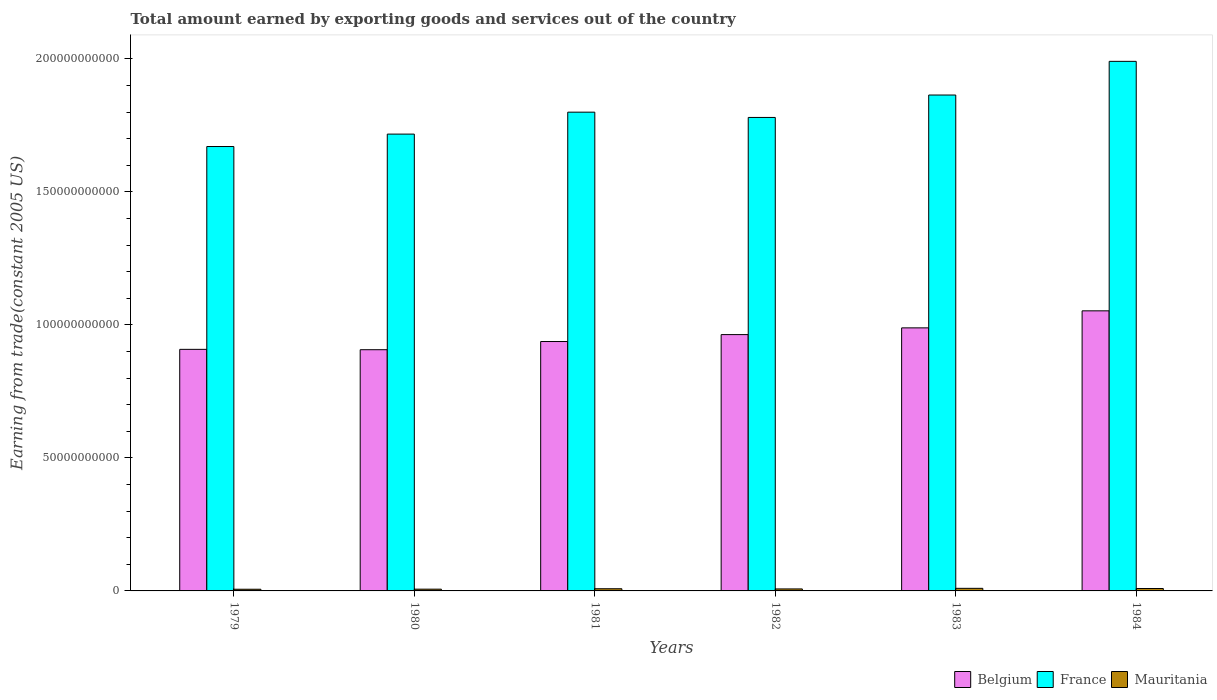How many different coloured bars are there?
Offer a very short reply. 3. Are the number of bars on each tick of the X-axis equal?
Your answer should be very brief. Yes. How many bars are there on the 2nd tick from the left?
Ensure brevity in your answer.  3. What is the label of the 2nd group of bars from the left?
Your answer should be compact. 1980. What is the total amount earned by exporting goods and services in Belgium in 1980?
Your answer should be compact. 9.07e+1. Across all years, what is the maximum total amount earned by exporting goods and services in Belgium?
Give a very brief answer. 1.05e+11. Across all years, what is the minimum total amount earned by exporting goods and services in Belgium?
Make the answer very short. 9.07e+1. In which year was the total amount earned by exporting goods and services in France minimum?
Ensure brevity in your answer.  1979. What is the total total amount earned by exporting goods and services in France in the graph?
Your response must be concise. 1.08e+12. What is the difference between the total amount earned by exporting goods and services in Belgium in 1979 and that in 1983?
Provide a succinct answer. -8.07e+09. What is the difference between the total amount earned by exporting goods and services in Belgium in 1982 and the total amount earned by exporting goods and services in Mauritania in 1983?
Provide a succinct answer. 9.54e+1. What is the average total amount earned by exporting goods and services in Mauritania per year?
Ensure brevity in your answer.  7.90e+08. In the year 1983, what is the difference between the total amount earned by exporting goods and services in Mauritania and total amount earned by exporting goods and services in Belgium?
Provide a succinct answer. -9.79e+1. In how many years, is the total amount earned by exporting goods and services in Belgium greater than 90000000000 US$?
Offer a terse response. 6. What is the ratio of the total amount earned by exporting goods and services in Belgium in 1980 to that in 1981?
Give a very brief answer. 0.97. Is the total amount earned by exporting goods and services in France in 1981 less than that in 1983?
Provide a short and direct response. Yes. Is the difference between the total amount earned by exporting goods and services in Mauritania in 1982 and 1983 greater than the difference between the total amount earned by exporting goods and services in Belgium in 1982 and 1983?
Your response must be concise. Yes. What is the difference between the highest and the second highest total amount earned by exporting goods and services in France?
Your answer should be compact. 1.27e+1. What is the difference between the highest and the lowest total amount earned by exporting goods and services in Belgium?
Your response must be concise. 1.46e+1. In how many years, is the total amount earned by exporting goods and services in France greater than the average total amount earned by exporting goods and services in France taken over all years?
Give a very brief answer. 2. Is the sum of the total amount earned by exporting goods and services in Mauritania in 1982 and 1984 greater than the maximum total amount earned by exporting goods and services in France across all years?
Provide a succinct answer. No. What does the 2nd bar from the left in 1979 represents?
Your answer should be compact. France. What does the 2nd bar from the right in 1980 represents?
Offer a very short reply. France. What is the difference between two consecutive major ticks on the Y-axis?
Ensure brevity in your answer.  5.00e+1. Are the values on the major ticks of Y-axis written in scientific E-notation?
Make the answer very short. No. Does the graph contain any zero values?
Keep it short and to the point. No. Where does the legend appear in the graph?
Offer a very short reply. Bottom right. How many legend labels are there?
Give a very brief answer. 3. What is the title of the graph?
Your answer should be compact. Total amount earned by exporting goods and services out of the country. Does "Cambodia" appear as one of the legend labels in the graph?
Keep it short and to the point. No. What is the label or title of the X-axis?
Provide a succinct answer. Years. What is the label or title of the Y-axis?
Your answer should be very brief. Earning from trade(constant 2005 US). What is the Earning from trade(constant 2005 US) in Belgium in 1979?
Offer a very short reply. 9.08e+1. What is the Earning from trade(constant 2005 US) of France in 1979?
Provide a succinct answer. 1.67e+11. What is the Earning from trade(constant 2005 US) of Mauritania in 1979?
Your response must be concise. 6.30e+08. What is the Earning from trade(constant 2005 US) in Belgium in 1980?
Your answer should be compact. 9.07e+1. What is the Earning from trade(constant 2005 US) in France in 1980?
Ensure brevity in your answer.  1.72e+11. What is the Earning from trade(constant 2005 US) in Mauritania in 1980?
Your answer should be very brief. 6.63e+08. What is the Earning from trade(constant 2005 US) of Belgium in 1981?
Keep it short and to the point. 9.38e+1. What is the Earning from trade(constant 2005 US) in France in 1981?
Keep it short and to the point. 1.80e+11. What is the Earning from trade(constant 2005 US) of Mauritania in 1981?
Give a very brief answer. 8.16e+08. What is the Earning from trade(constant 2005 US) of Belgium in 1982?
Your response must be concise. 9.64e+1. What is the Earning from trade(constant 2005 US) in France in 1982?
Your answer should be very brief. 1.78e+11. What is the Earning from trade(constant 2005 US) of Mauritania in 1982?
Keep it short and to the point. 7.49e+08. What is the Earning from trade(constant 2005 US) in Belgium in 1983?
Offer a terse response. 9.89e+1. What is the Earning from trade(constant 2005 US) in France in 1983?
Offer a terse response. 1.86e+11. What is the Earning from trade(constant 2005 US) of Mauritania in 1983?
Provide a succinct answer. 9.72e+08. What is the Earning from trade(constant 2005 US) of Belgium in 1984?
Ensure brevity in your answer.  1.05e+11. What is the Earning from trade(constant 2005 US) of France in 1984?
Provide a succinct answer. 1.99e+11. What is the Earning from trade(constant 2005 US) in Mauritania in 1984?
Your answer should be compact. 9.08e+08. Across all years, what is the maximum Earning from trade(constant 2005 US) of Belgium?
Offer a terse response. 1.05e+11. Across all years, what is the maximum Earning from trade(constant 2005 US) of France?
Keep it short and to the point. 1.99e+11. Across all years, what is the maximum Earning from trade(constant 2005 US) of Mauritania?
Your response must be concise. 9.72e+08. Across all years, what is the minimum Earning from trade(constant 2005 US) of Belgium?
Provide a short and direct response. 9.07e+1. Across all years, what is the minimum Earning from trade(constant 2005 US) of France?
Ensure brevity in your answer.  1.67e+11. Across all years, what is the minimum Earning from trade(constant 2005 US) of Mauritania?
Offer a terse response. 6.30e+08. What is the total Earning from trade(constant 2005 US) in Belgium in the graph?
Offer a terse response. 5.76e+11. What is the total Earning from trade(constant 2005 US) in France in the graph?
Your response must be concise. 1.08e+12. What is the total Earning from trade(constant 2005 US) in Mauritania in the graph?
Your response must be concise. 4.74e+09. What is the difference between the Earning from trade(constant 2005 US) of Belgium in 1979 and that in 1980?
Offer a terse response. 1.37e+08. What is the difference between the Earning from trade(constant 2005 US) in France in 1979 and that in 1980?
Provide a succinct answer. -4.67e+09. What is the difference between the Earning from trade(constant 2005 US) in Mauritania in 1979 and that in 1980?
Your response must be concise. -3.37e+07. What is the difference between the Earning from trade(constant 2005 US) of Belgium in 1979 and that in 1981?
Your response must be concise. -2.94e+09. What is the difference between the Earning from trade(constant 2005 US) in France in 1979 and that in 1981?
Your answer should be compact. -1.29e+1. What is the difference between the Earning from trade(constant 2005 US) of Mauritania in 1979 and that in 1981?
Keep it short and to the point. -1.87e+08. What is the difference between the Earning from trade(constant 2005 US) in Belgium in 1979 and that in 1982?
Your answer should be very brief. -5.54e+09. What is the difference between the Earning from trade(constant 2005 US) of France in 1979 and that in 1982?
Your answer should be very brief. -1.09e+1. What is the difference between the Earning from trade(constant 2005 US) in Mauritania in 1979 and that in 1982?
Your answer should be compact. -1.19e+08. What is the difference between the Earning from trade(constant 2005 US) in Belgium in 1979 and that in 1983?
Your answer should be very brief. -8.07e+09. What is the difference between the Earning from trade(constant 2005 US) in France in 1979 and that in 1983?
Offer a very short reply. -1.94e+1. What is the difference between the Earning from trade(constant 2005 US) in Mauritania in 1979 and that in 1983?
Make the answer very short. -3.42e+08. What is the difference between the Earning from trade(constant 2005 US) in Belgium in 1979 and that in 1984?
Give a very brief answer. -1.45e+1. What is the difference between the Earning from trade(constant 2005 US) in France in 1979 and that in 1984?
Offer a terse response. -3.20e+1. What is the difference between the Earning from trade(constant 2005 US) of Mauritania in 1979 and that in 1984?
Offer a terse response. -2.78e+08. What is the difference between the Earning from trade(constant 2005 US) of Belgium in 1980 and that in 1981?
Provide a short and direct response. -3.08e+09. What is the difference between the Earning from trade(constant 2005 US) of France in 1980 and that in 1981?
Offer a very short reply. -8.25e+09. What is the difference between the Earning from trade(constant 2005 US) in Mauritania in 1980 and that in 1981?
Offer a very short reply. -1.53e+08. What is the difference between the Earning from trade(constant 2005 US) of Belgium in 1980 and that in 1982?
Offer a terse response. -5.68e+09. What is the difference between the Earning from trade(constant 2005 US) of France in 1980 and that in 1982?
Your answer should be very brief. -6.26e+09. What is the difference between the Earning from trade(constant 2005 US) in Mauritania in 1980 and that in 1982?
Make the answer very short. -8.58e+07. What is the difference between the Earning from trade(constant 2005 US) in Belgium in 1980 and that in 1983?
Your answer should be very brief. -8.21e+09. What is the difference between the Earning from trade(constant 2005 US) in France in 1980 and that in 1983?
Provide a succinct answer. -1.47e+1. What is the difference between the Earning from trade(constant 2005 US) in Mauritania in 1980 and that in 1983?
Offer a very short reply. -3.09e+08. What is the difference between the Earning from trade(constant 2005 US) of Belgium in 1980 and that in 1984?
Make the answer very short. -1.46e+1. What is the difference between the Earning from trade(constant 2005 US) of France in 1980 and that in 1984?
Ensure brevity in your answer.  -2.73e+1. What is the difference between the Earning from trade(constant 2005 US) of Mauritania in 1980 and that in 1984?
Ensure brevity in your answer.  -2.45e+08. What is the difference between the Earning from trade(constant 2005 US) of Belgium in 1981 and that in 1982?
Give a very brief answer. -2.61e+09. What is the difference between the Earning from trade(constant 2005 US) of France in 1981 and that in 1982?
Make the answer very short. 1.98e+09. What is the difference between the Earning from trade(constant 2005 US) of Mauritania in 1981 and that in 1982?
Offer a very short reply. 6.73e+07. What is the difference between the Earning from trade(constant 2005 US) in Belgium in 1981 and that in 1983?
Ensure brevity in your answer.  -5.14e+09. What is the difference between the Earning from trade(constant 2005 US) in France in 1981 and that in 1983?
Provide a succinct answer. -6.44e+09. What is the difference between the Earning from trade(constant 2005 US) of Mauritania in 1981 and that in 1983?
Provide a succinct answer. -1.55e+08. What is the difference between the Earning from trade(constant 2005 US) in Belgium in 1981 and that in 1984?
Offer a terse response. -1.15e+1. What is the difference between the Earning from trade(constant 2005 US) of France in 1981 and that in 1984?
Provide a succinct answer. -1.91e+1. What is the difference between the Earning from trade(constant 2005 US) of Mauritania in 1981 and that in 1984?
Provide a succinct answer. -9.16e+07. What is the difference between the Earning from trade(constant 2005 US) in Belgium in 1982 and that in 1983?
Provide a succinct answer. -2.53e+09. What is the difference between the Earning from trade(constant 2005 US) in France in 1982 and that in 1983?
Make the answer very short. -8.42e+09. What is the difference between the Earning from trade(constant 2005 US) in Mauritania in 1982 and that in 1983?
Make the answer very short. -2.23e+08. What is the difference between the Earning from trade(constant 2005 US) of Belgium in 1982 and that in 1984?
Keep it short and to the point. -8.93e+09. What is the difference between the Earning from trade(constant 2005 US) in France in 1982 and that in 1984?
Offer a terse response. -2.11e+1. What is the difference between the Earning from trade(constant 2005 US) of Mauritania in 1982 and that in 1984?
Provide a short and direct response. -1.59e+08. What is the difference between the Earning from trade(constant 2005 US) in Belgium in 1983 and that in 1984?
Your answer should be compact. -6.40e+09. What is the difference between the Earning from trade(constant 2005 US) of France in 1983 and that in 1984?
Ensure brevity in your answer.  -1.27e+1. What is the difference between the Earning from trade(constant 2005 US) of Mauritania in 1983 and that in 1984?
Give a very brief answer. 6.39e+07. What is the difference between the Earning from trade(constant 2005 US) of Belgium in 1979 and the Earning from trade(constant 2005 US) of France in 1980?
Give a very brief answer. -8.09e+1. What is the difference between the Earning from trade(constant 2005 US) in Belgium in 1979 and the Earning from trade(constant 2005 US) in Mauritania in 1980?
Give a very brief answer. 9.02e+1. What is the difference between the Earning from trade(constant 2005 US) of France in 1979 and the Earning from trade(constant 2005 US) of Mauritania in 1980?
Offer a terse response. 1.66e+11. What is the difference between the Earning from trade(constant 2005 US) in Belgium in 1979 and the Earning from trade(constant 2005 US) in France in 1981?
Give a very brief answer. -8.92e+1. What is the difference between the Earning from trade(constant 2005 US) in Belgium in 1979 and the Earning from trade(constant 2005 US) in Mauritania in 1981?
Keep it short and to the point. 9.00e+1. What is the difference between the Earning from trade(constant 2005 US) of France in 1979 and the Earning from trade(constant 2005 US) of Mauritania in 1981?
Offer a very short reply. 1.66e+11. What is the difference between the Earning from trade(constant 2005 US) in Belgium in 1979 and the Earning from trade(constant 2005 US) in France in 1982?
Provide a short and direct response. -8.72e+1. What is the difference between the Earning from trade(constant 2005 US) of Belgium in 1979 and the Earning from trade(constant 2005 US) of Mauritania in 1982?
Make the answer very short. 9.01e+1. What is the difference between the Earning from trade(constant 2005 US) in France in 1979 and the Earning from trade(constant 2005 US) in Mauritania in 1982?
Provide a short and direct response. 1.66e+11. What is the difference between the Earning from trade(constant 2005 US) of Belgium in 1979 and the Earning from trade(constant 2005 US) of France in 1983?
Your response must be concise. -9.56e+1. What is the difference between the Earning from trade(constant 2005 US) of Belgium in 1979 and the Earning from trade(constant 2005 US) of Mauritania in 1983?
Give a very brief answer. 8.98e+1. What is the difference between the Earning from trade(constant 2005 US) in France in 1979 and the Earning from trade(constant 2005 US) in Mauritania in 1983?
Ensure brevity in your answer.  1.66e+11. What is the difference between the Earning from trade(constant 2005 US) of Belgium in 1979 and the Earning from trade(constant 2005 US) of France in 1984?
Ensure brevity in your answer.  -1.08e+11. What is the difference between the Earning from trade(constant 2005 US) of Belgium in 1979 and the Earning from trade(constant 2005 US) of Mauritania in 1984?
Provide a succinct answer. 8.99e+1. What is the difference between the Earning from trade(constant 2005 US) in France in 1979 and the Earning from trade(constant 2005 US) in Mauritania in 1984?
Give a very brief answer. 1.66e+11. What is the difference between the Earning from trade(constant 2005 US) in Belgium in 1980 and the Earning from trade(constant 2005 US) in France in 1981?
Give a very brief answer. -8.93e+1. What is the difference between the Earning from trade(constant 2005 US) of Belgium in 1980 and the Earning from trade(constant 2005 US) of Mauritania in 1981?
Your answer should be very brief. 8.99e+1. What is the difference between the Earning from trade(constant 2005 US) of France in 1980 and the Earning from trade(constant 2005 US) of Mauritania in 1981?
Give a very brief answer. 1.71e+11. What is the difference between the Earning from trade(constant 2005 US) in Belgium in 1980 and the Earning from trade(constant 2005 US) in France in 1982?
Ensure brevity in your answer.  -8.73e+1. What is the difference between the Earning from trade(constant 2005 US) of Belgium in 1980 and the Earning from trade(constant 2005 US) of Mauritania in 1982?
Give a very brief answer. 8.99e+1. What is the difference between the Earning from trade(constant 2005 US) in France in 1980 and the Earning from trade(constant 2005 US) in Mauritania in 1982?
Offer a very short reply. 1.71e+11. What is the difference between the Earning from trade(constant 2005 US) in Belgium in 1980 and the Earning from trade(constant 2005 US) in France in 1983?
Your response must be concise. -9.57e+1. What is the difference between the Earning from trade(constant 2005 US) in Belgium in 1980 and the Earning from trade(constant 2005 US) in Mauritania in 1983?
Provide a succinct answer. 8.97e+1. What is the difference between the Earning from trade(constant 2005 US) in France in 1980 and the Earning from trade(constant 2005 US) in Mauritania in 1983?
Your response must be concise. 1.71e+11. What is the difference between the Earning from trade(constant 2005 US) in Belgium in 1980 and the Earning from trade(constant 2005 US) in France in 1984?
Keep it short and to the point. -1.08e+11. What is the difference between the Earning from trade(constant 2005 US) in Belgium in 1980 and the Earning from trade(constant 2005 US) in Mauritania in 1984?
Ensure brevity in your answer.  8.98e+1. What is the difference between the Earning from trade(constant 2005 US) in France in 1980 and the Earning from trade(constant 2005 US) in Mauritania in 1984?
Your answer should be compact. 1.71e+11. What is the difference between the Earning from trade(constant 2005 US) of Belgium in 1981 and the Earning from trade(constant 2005 US) of France in 1982?
Make the answer very short. -8.42e+1. What is the difference between the Earning from trade(constant 2005 US) of Belgium in 1981 and the Earning from trade(constant 2005 US) of Mauritania in 1982?
Your answer should be compact. 9.30e+1. What is the difference between the Earning from trade(constant 2005 US) of France in 1981 and the Earning from trade(constant 2005 US) of Mauritania in 1982?
Ensure brevity in your answer.  1.79e+11. What is the difference between the Earning from trade(constant 2005 US) of Belgium in 1981 and the Earning from trade(constant 2005 US) of France in 1983?
Offer a terse response. -9.27e+1. What is the difference between the Earning from trade(constant 2005 US) in Belgium in 1981 and the Earning from trade(constant 2005 US) in Mauritania in 1983?
Give a very brief answer. 9.28e+1. What is the difference between the Earning from trade(constant 2005 US) of France in 1981 and the Earning from trade(constant 2005 US) of Mauritania in 1983?
Make the answer very short. 1.79e+11. What is the difference between the Earning from trade(constant 2005 US) of Belgium in 1981 and the Earning from trade(constant 2005 US) of France in 1984?
Give a very brief answer. -1.05e+11. What is the difference between the Earning from trade(constant 2005 US) in Belgium in 1981 and the Earning from trade(constant 2005 US) in Mauritania in 1984?
Your answer should be very brief. 9.28e+1. What is the difference between the Earning from trade(constant 2005 US) in France in 1981 and the Earning from trade(constant 2005 US) in Mauritania in 1984?
Give a very brief answer. 1.79e+11. What is the difference between the Earning from trade(constant 2005 US) in Belgium in 1982 and the Earning from trade(constant 2005 US) in France in 1983?
Your answer should be compact. -9.01e+1. What is the difference between the Earning from trade(constant 2005 US) in Belgium in 1982 and the Earning from trade(constant 2005 US) in Mauritania in 1983?
Offer a very short reply. 9.54e+1. What is the difference between the Earning from trade(constant 2005 US) in France in 1982 and the Earning from trade(constant 2005 US) in Mauritania in 1983?
Keep it short and to the point. 1.77e+11. What is the difference between the Earning from trade(constant 2005 US) in Belgium in 1982 and the Earning from trade(constant 2005 US) in France in 1984?
Your response must be concise. -1.03e+11. What is the difference between the Earning from trade(constant 2005 US) in Belgium in 1982 and the Earning from trade(constant 2005 US) in Mauritania in 1984?
Make the answer very short. 9.54e+1. What is the difference between the Earning from trade(constant 2005 US) of France in 1982 and the Earning from trade(constant 2005 US) of Mauritania in 1984?
Keep it short and to the point. 1.77e+11. What is the difference between the Earning from trade(constant 2005 US) in Belgium in 1983 and the Earning from trade(constant 2005 US) in France in 1984?
Give a very brief answer. -1.00e+11. What is the difference between the Earning from trade(constant 2005 US) of Belgium in 1983 and the Earning from trade(constant 2005 US) of Mauritania in 1984?
Your answer should be compact. 9.80e+1. What is the difference between the Earning from trade(constant 2005 US) of France in 1983 and the Earning from trade(constant 2005 US) of Mauritania in 1984?
Your response must be concise. 1.86e+11. What is the average Earning from trade(constant 2005 US) of Belgium per year?
Provide a succinct answer. 9.60e+1. What is the average Earning from trade(constant 2005 US) in France per year?
Give a very brief answer. 1.80e+11. What is the average Earning from trade(constant 2005 US) in Mauritania per year?
Make the answer very short. 7.90e+08. In the year 1979, what is the difference between the Earning from trade(constant 2005 US) in Belgium and Earning from trade(constant 2005 US) in France?
Your answer should be compact. -7.62e+1. In the year 1979, what is the difference between the Earning from trade(constant 2005 US) in Belgium and Earning from trade(constant 2005 US) in Mauritania?
Provide a short and direct response. 9.02e+1. In the year 1979, what is the difference between the Earning from trade(constant 2005 US) of France and Earning from trade(constant 2005 US) of Mauritania?
Ensure brevity in your answer.  1.66e+11. In the year 1980, what is the difference between the Earning from trade(constant 2005 US) in Belgium and Earning from trade(constant 2005 US) in France?
Provide a succinct answer. -8.11e+1. In the year 1980, what is the difference between the Earning from trade(constant 2005 US) of Belgium and Earning from trade(constant 2005 US) of Mauritania?
Provide a succinct answer. 9.00e+1. In the year 1980, what is the difference between the Earning from trade(constant 2005 US) of France and Earning from trade(constant 2005 US) of Mauritania?
Provide a succinct answer. 1.71e+11. In the year 1981, what is the difference between the Earning from trade(constant 2005 US) of Belgium and Earning from trade(constant 2005 US) of France?
Offer a terse response. -8.62e+1. In the year 1981, what is the difference between the Earning from trade(constant 2005 US) of Belgium and Earning from trade(constant 2005 US) of Mauritania?
Your answer should be very brief. 9.29e+1. In the year 1981, what is the difference between the Earning from trade(constant 2005 US) of France and Earning from trade(constant 2005 US) of Mauritania?
Offer a terse response. 1.79e+11. In the year 1982, what is the difference between the Earning from trade(constant 2005 US) in Belgium and Earning from trade(constant 2005 US) in France?
Your answer should be compact. -8.16e+1. In the year 1982, what is the difference between the Earning from trade(constant 2005 US) in Belgium and Earning from trade(constant 2005 US) in Mauritania?
Keep it short and to the point. 9.56e+1. In the year 1982, what is the difference between the Earning from trade(constant 2005 US) of France and Earning from trade(constant 2005 US) of Mauritania?
Your answer should be very brief. 1.77e+11. In the year 1983, what is the difference between the Earning from trade(constant 2005 US) in Belgium and Earning from trade(constant 2005 US) in France?
Ensure brevity in your answer.  -8.75e+1. In the year 1983, what is the difference between the Earning from trade(constant 2005 US) in Belgium and Earning from trade(constant 2005 US) in Mauritania?
Make the answer very short. 9.79e+1. In the year 1983, what is the difference between the Earning from trade(constant 2005 US) of France and Earning from trade(constant 2005 US) of Mauritania?
Ensure brevity in your answer.  1.85e+11. In the year 1984, what is the difference between the Earning from trade(constant 2005 US) of Belgium and Earning from trade(constant 2005 US) of France?
Give a very brief answer. -9.38e+1. In the year 1984, what is the difference between the Earning from trade(constant 2005 US) in Belgium and Earning from trade(constant 2005 US) in Mauritania?
Offer a very short reply. 1.04e+11. In the year 1984, what is the difference between the Earning from trade(constant 2005 US) in France and Earning from trade(constant 2005 US) in Mauritania?
Your answer should be very brief. 1.98e+11. What is the ratio of the Earning from trade(constant 2005 US) of Belgium in 1979 to that in 1980?
Your response must be concise. 1. What is the ratio of the Earning from trade(constant 2005 US) in France in 1979 to that in 1980?
Make the answer very short. 0.97. What is the ratio of the Earning from trade(constant 2005 US) of Mauritania in 1979 to that in 1980?
Your response must be concise. 0.95. What is the ratio of the Earning from trade(constant 2005 US) in Belgium in 1979 to that in 1981?
Your answer should be very brief. 0.97. What is the ratio of the Earning from trade(constant 2005 US) in France in 1979 to that in 1981?
Your response must be concise. 0.93. What is the ratio of the Earning from trade(constant 2005 US) in Mauritania in 1979 to that in 1981?
Keep it short and to the point. 0.77. What is the ratio of the Earning from trade(constant 2005 US) of Belgium in 1979 to that in 1982?
Your answer should be compact. 0.94. What is the ratio of the Earning from trade(constant 2005 US) in France in 1979 to that in 1982?
Offer a very short reply. 0.94. What is the ratio of the Earning from trade(constant 2005 US) of Mauritania in 1979 to that in 1982?
Provide a short and direct response. 0.84. What is the ratio of the Earning from trade(constant 2005 US) in Belgium in 1979 to that in 1983?
Your answer should be compact. 0.92. What is the ratio of the Earning from trade(constant 2005 US) in France in 1979 to that in 1983?
Your answer should be very brief. 0.9. What is the ratio of the Earning from trade(constant 2005 US) of Mauritania in 1979 to that in 1983?
Your answer should be very brief. 0.65. What is the ratio of the Earning from trade(constant 2005 US) of Belgium in 1979 to that in 1984?
Provide a short and direct response. 0.86. What is the ratio of the Earning from trade(constant 2005 US) in France in 1979 to that in 1984?
Provide a short and direct response. 0.84. What is the ratio of the Earning from trade(constant 2005 US) of Mauritania in 1979 to that in 1984?
Offer a terse response. 0.69. What is the ratio of the Earning from trade(constant 2005 US) in Belgium in 1980 to that in 1981?
Your answer should be very brief. 0.97. What is the ratio of the Earning from trade(constant 2005 US) of France in 1980 to that in 1981?
Make the answer very short. 0.95. What is the ratio of the Earning from trade(constant 2005 US) in Mauritania in 1980 to that in 1981?
Make the answer very short. 0.81. What is the ratio of the Earning from trade(constant 2005 US) of Belgium in 1980 to that in 1982?
Ensure brevity in your answer.  0.94. What is the ratio of the Earning from trade(constant 2005 US) in France in 1980 to that in 1982?
Provide a short and direct response. 0.96. What is the ratio of the Earning from trade(constant 2005 US) of Mauritania in 1980 to that in 1982?
Provide a succinct answer. 0.89. What is the ratio of the Earning from trade(constant 2005 US) in Belgium in 1980 to that in 1983?
Provide a short and direct response. 0.92. What is the ratio of the Earning from trade(constant 2005 US) of France in 1980 to that in 1983?
Provide a succinct answer. 0.92. What is the ratio of the Earning from trade(constant 2005 US) of Mauritania in 1980 to that in 1983?
Offer a very short reply. 0.68. What is the ratio of the Earning from trade(constant 2005 US) in Belgium in 1980 to that in 1984?
Your response must be concise. 0.86. What is the ratio of the Earning from trade(constant 2005 US) of France in 1980 to that in 1984?
Make the answer very short. 0.86. What is the ratio of the Earning from trade(constant 2005 US) in Mauritania in 1980 to that in 1984?
Offer a terse response. 0.73. What is the ratio of the Earning from trade(constant 2005 US) in France in 1981 to that in 1982?
Offer a terse response. 1.01. What is the ratio of the Earning from trade(constant 2005 US) of Mauritania in 1981 to that in 1982?
Ensure brevity in your answer.  1.09. What is the ratio of the Earning from trade(constant 2005 US) in Belgium in 1981 to that in 1983?
Ensure brevity in your answer.  0.95. What is the ratio of the Earning from trade(constant 2005 US) in France in 1981 to that in 1983?
Keep it short and to the point. 0.97. What is the ratio of the Earning from trade(constant 2005 US) of Mauritania in 1981 to that in 1983?
Your response must be concise. 0.84. What is the ratio of the Earning from trade(constant 2005 US) in Belgium in 1981 to that in 1984?
Keep it short and to the point. 0.89. What is the ratio of the Earning from trade(constant 2005 US) in France in 1981 to that in 1984?
Make the answer very short. 0.9. What is the ratio of the Earning from trade(constant 2005 US) in Mauritania in 1981 to that in 1984?
Offer a terse response. 0.9. What is the ratio of the Earning from trade(constant 2005 US) of Belgium in 1982 to that in 1983?
Keep it short and to the point. 0.97. What is the ratio of the Earning from trade(constant 2005 US) of France in 1982 to that in 1983?
Offer a terse response. 0.95. What is the ratio of the Earning from trade(constant 2005 US) in Mauritania in 1982 to that in 1983?
Give a very brief answer. 0.77. What is the ratio of the Earning from trade(constant 2005 US) of Belgium in 1982 to that in 1984?
Offer a very short reply. 0.92. What is the ratio of the Earning from trade(constant 2005 US) in France in 1982 to that in 1984?
Offer a terse response. 0.89. What is the ratio of the Earning from trade(constant 2005 US) of Mauritania in 1982 to that in 1984?
Ensure brevity in your answer.  0.82. What is the ratio of the Earning from trade(constant 2005 US) in Belgium in 1983 to that in 1984?
Give a very brief answer. 0.94. What is the ratio of the Earning from trade(constant 2005 US) of France in 1983 to that in 1984?
Keep it short and to the point. 0.94. What is the ratio of the Earning from trade(constant 2005 US) in Mauritania in 1983 to that in 1984?
Ensure brevity in your answer.  1.07. What is the difference between the highest and the second highest Earning from trade(constant 2005 US) of Belgium?
Give a very brief answer. 6.40e+09. What is the difference between the highest and the second highest Earning from trade(constant 2005 US) in France?
Offer a terse response. 1.27e+1. What is the difference between the highest and the second highest Earning from trade(constant 2005 US) in Mauritania?
Give a very brief answer. 6.39e+07. What is the difference between the highest and the lowest Earning from trade(constant 2005 US) of Belgium?
Your answer should be compact. 1.46e+1. What is the difference between the highest and the lowest Earning from trade(constant 2005 US) in France?
Provide a succinct answer. 3.20e+1. What is the difference between the highest and the lowest Earning from trade(constant 2005 US) of Mauritania?
Make the answer very short. 3.42e+08. 